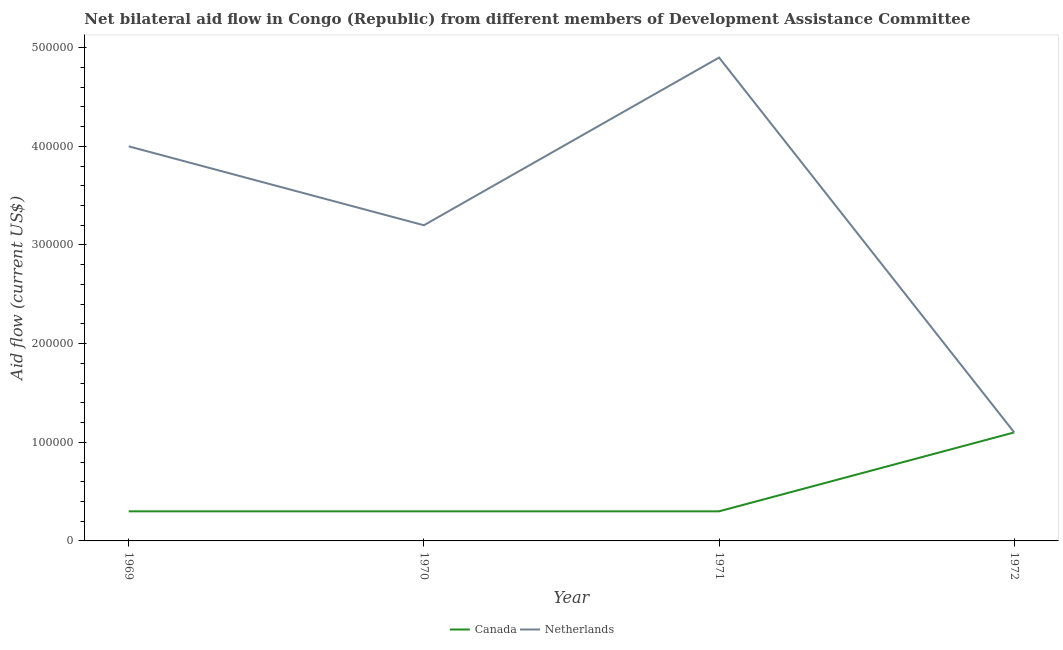Does the line corresponding to amount of aid given by netherlands intersect with the line corresponding to amount of aid given by canada?
Offer a very short reply. Yes. What is the amount of aid given by canada in 1971?
Offer a terse response. 3.00e+04. Across all years, what is the maximum amount of aid given by canada?
Offer a terse response. 1.10e+05. Across all years, what is the minimum amount of aid given by canada?
Provide a short and direct response. 3.00e+04. In which year was the amount of aid given by canada maximum?
Your answer should be very brief. 1972. What is the total amount of aid given by canada in the graph?
Offer a terse response. 2.00e+05. What is the difference between the amount of aid given by netherlands in 1969 and that in 1970?
Your answer should be very brief. 8.00e+04. What is the difference between the amount of aid given by netherlands in 1969 and the amount of aid given by canada in 1970?
Keep it short and to the point. 3.70e+05. What is the average amount of aid given by canada per year?
Give a very brief answer. 5.00e+04. In how many years, is the amount of aid given by canada greater than 440000 US$?
Your answer should be very brief. 0. What is the difference between the highest and the second highest amount of aid given by canada?
Your answer should be compact. 8.00e+04. What is the difference between the highest and the lowest amount of aid given by netherlands?
Your answer should be very brief. 3.80e+05. In how many years, is the amount of aid given by canada greater than the average amount of aid given by canada taken over all years?
Provide a short and direct response. 1. Is the amount of aid given by netherlands strictly less than the amount of aid given by canada over the years?
Your answer should be compact. No. Does the graph contain grids?
Provide a succinct answer. No. Where does the legend appear in the graph?
Keep it short and to the point. Bottom center. What is the title of the graph?
Your answer should be very brief. Net bilateral aid flow in Congo (Republic) from different members of Development Assistance Committee. What is the label or title of the X-axis?
Make the answer very short. Year. What is the Aid flow (current US$) in Canada in 1969?
Make the answer very short. 3.00e+04. What is the Aid flow (current US$) in Netherlands in 1969?
Your answer should be very brief. 4.00e+05. What is the Aid flow (current US$) in Canada in 1970?
Ensure brevity in your answer.  3.00e+04. What is the Aid flow (current US$) of Netherlands in 1970?
Provide a short and direct response. 3.20e+05. What is the Aid flow (current US$) of Netherlands in 1971?
Your answer should be very brief. 4.90e+05. What is the Aid flow (current US$) of Canada in 1972?
Ensure brevity in your answer.  1.10e+05. Across all years, what is the maximum Aid flow (current US$) of Netherlands?
Offer a very short reply. 4.90e+05. Across all years, what is the minimum Aid flow (current US$) in Netherlands?
Offer a very short reply. 1.10e+05. What is the total Aid flow (current US$) in Netherlands in the graph?
Give a very brief answer. 1.32e+06. What is the difference between the Aid flow (current US$) in Netherlands in 1969 and that in 1970?
Your answer should be compact. 8.00e+04. What is the difference between the Aid flow (current US$) of Canada in 1969 and that in 1971?
Ensure brevity in your answer.  0. What is the difference between the Aid flow (current US$) in Canada in 1969 and that in 1972?
Make the answer very short. -8.00e+04. What is the difference between the Aid flow (current US$) in Netherlands in 1969 and that in 1972?
Your answer should be very brief. 2.90e+05. What is the difference between the Aid flow (current US$) in Netherlands in 1970 and that in 1972?
Your response must be concise. 2.10e+05. What is the difference between the Aid flow (current US$) in Canada in 1971 and that in 1972?
Ensure brevity in your answer.  -8.00e+04. What is the difference between the Aid flow (current US$) of Canada in 1969 and the Aid flow (current US$) of Netherlands in 1971?
Offer a terse response. -4.60e+05. What is the difference between the Aid flow (current US$) in Canada in 1970 and the Aid flow (current US$) in Netherlands in 1971?
Your response must be concise. -4.60e+05. What is the difference between the Aid flow (current US$) in Canada in 1970 and the Aid flow (current US$) in Netherlands in 1972?
Your answer should be very brief. -8.00e+04. What is the difference between the Aid flow (current US$) of Canada in 1971 and the Aid flow (current US$) of Netherlands in 1972?
Ensure brevity in your answer.  -8.00e+04. What is the average Aid flow (current US$) of Canada per year?
Your answer should be compact. 5.00e+04. In the year 1969, what is the difference between the Aid flow (current US$) in Canada and Aid flow (current US$) in Netherlands?
Keep it short and to the point. -3.70e+05. In the year 1971, what is the difference between the Aid flow (current US$) in Canada and Aid flow (current US$) in Netherlands?
Provide a succinct answer. -4.60e+05. What is the ratio of the Aid flow (current US$) of Netherlands in 1969 to that in 1970?
Your answer should be compact. 1.25. What is the ratio of the Aid flow (current US$) of Netherlands in 1969 to that in 1971?
Ensure brevity in your answer.  0.82. What is the ratio of the Aid flow (current US$) in Canada in 1969 to that in 1972?
Keep it short and to the point. 0.27. What is the ratio of the Aid flow (current US$) of Netherlands in 1969 to that in 1972?
Make the answer very short. 3.64. What is the ratio of the Aid flow (current US$) in Netherlands in 1970 to that in 1971?
Offer a terse response. 0.65. What is the ratio of the Aid flow (current US$) in Canada in 1970 to that in 1972?
Offer a terse response. 0.27. What is the ratio of the Aid flow (current US$) of Netherlands in 1970 to that in 1972?
Provide a succinct answer. 2.91. What is the ratio of the Aid flow (current US$) in Canada in 1971 to that in 1972?
Provide a succinct answer. 0.27. What is the ratio of the Aid flow (current US$) in Netherlands in 1971 to that in 1972?
Give a very brief answer. 4.45. What is the difference between the highest and the second highest Aid flow (current US$) of Canada?
Your answer should be compact. 8.00e+04. 